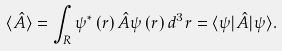<formula> <loc_0><loc_0><loc_500><loc_500>\langle { \hat { A } } \rangle = \int _ { R } \psi ^ { * } \left ( r \right ) { \hat { A } } \psi \left ( r \right ) d ^ { 3 } r = \langle \psi | { \hat { A } } | \psi \rangle .</formula> 